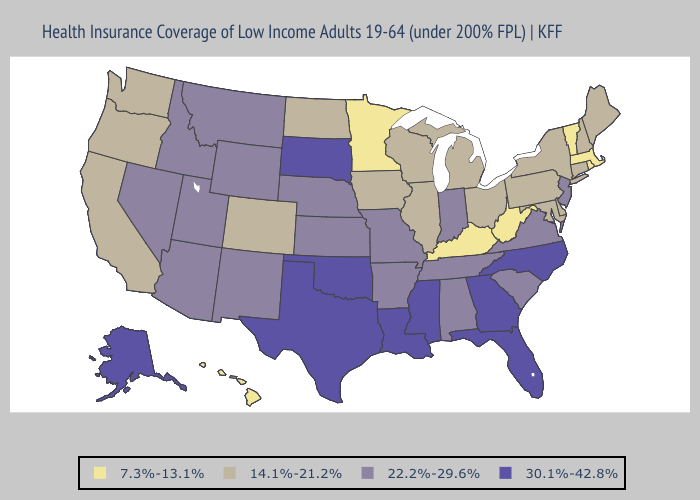What is the value of Indiana?
Quick response, please. 22.2%-29.6%. Does Illinois have a higher value than New Mexico?
Keep it brief. No. Among the states that border Idaho , which have the highest value?
Short answer required. Montana, Nevada, Utah, Wyoming. Name the states that have a value in the range 7.3%-13.1%?
Give a very brief answer. Hawaii, Kentucky, Massachusetts, Minnesota, Rhode Island, Vermont, West Virginia. Among the states that border Minnesota , does Wisconsin have the highest value?
Answer briefly. No. Is the legend a continuous bar?
Answer briefly. No. Does Hawaii have the lowest value in the West?
Keep it brief. Yes. Name the states that have a value in the range 7.3%-13.1%?
Keep it brief. Hawaii, Kentucky, Massachusetts, Minnesota, Rhode Island, Vermont, West Virginia. Does Rhode Island have the lowest value in the USA?
Answer briefly. Yes. Does Florida have the highest value in the USA?
Write a very short answer. Yes. Which states have the lowest value in the USA?
Short answer required. Hawaii, Kentucky, Massachusetts, Minnesota, Rhode Island, Vermont, West Virginia. Name the states that have a value in the range 22.2%-29.6%?
Concise answer only. Alabama, Arizona, Arkansas, Idaho, Indiana, Kansas, Missouri, Montana, Nebraska, Nevada, New Jersey, New Mexico, South Carolina, Tennessee, Utah, Virginia, Wyoming. Name the states that have a value in the range 22.2%-29.6%?
Keep it brief. Alabama, Arizona, Arkansas, Idaho, Indiana, Kansas, Missouri, Montana, Nebraska, Nevada, New Jersey, New Mexico, South Carolina, Tennessee, Utah, Virginia, Wyoming. Name the states that have a value in the range 22.2%-29.6%?
Answer briefly. Alabama, Arizona, Arkansas, Idaho, Indiana, Kansas, Missouri, Montana, Nebraska, Nevada, New Jersey, New Mexico, South Carolina, Tennessee, Utah, Virginia, Wyoming. Does Louisiana have the highest value in the USA?
Short answer required. Yes. 